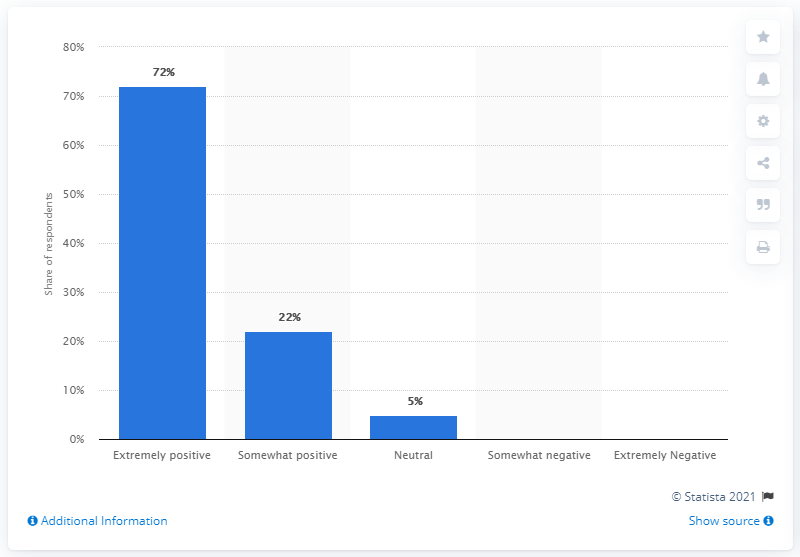List a handful of essential elements in this visual. Seventy-two percent of the respondents rated Under Armour's quality as extremely positive. 